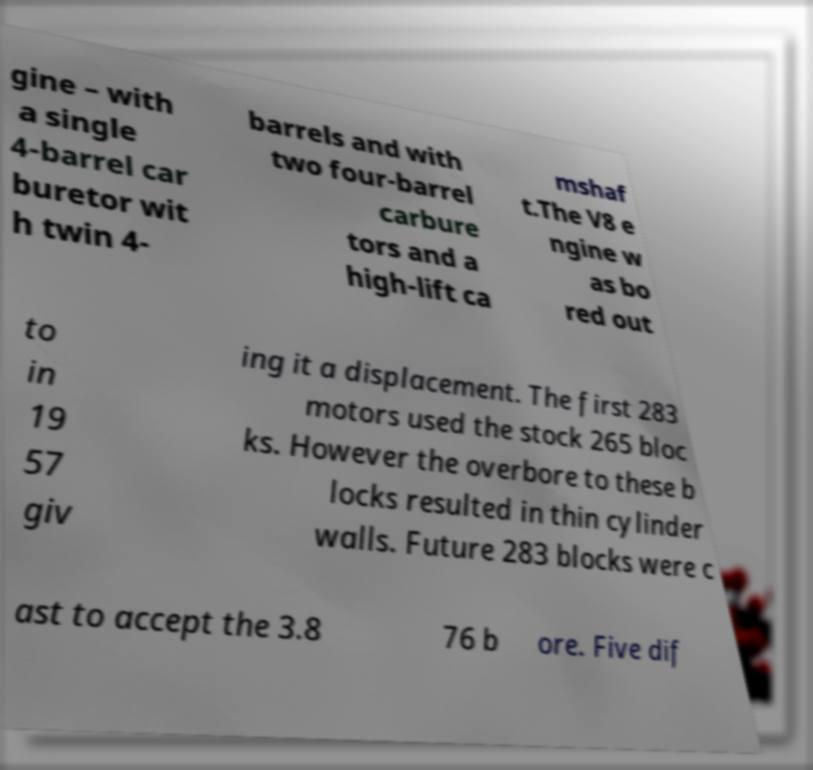Could you extract and type out the text from this image? gine – with a single 4-barrel car buretor wit h twin 4- barrels and with two four-barrel carbure tors and a high-lift ca mshaf t.The V8 e ngine w as bo red out to in 19 57 giv ing it a displacement. The first 283 motors used the stock 265 bloc ks. However the overbore to these b locks resulted in thin cylinder walls. Future 283 blocks were c ast to accept the 3.8 76 b ore. Five dif 